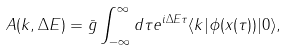Convert formula to latex. <formula><loc_0><loc_0><loc_500><loc_500>A ( k , \Delta E ) = \bar { g } \int _ { - \infty } ^ { \infty } d \tau e ^ { i \Delta E \tau } \langle k | \phi ( x ( \tau ) ) | 0 \rangle ,</formula> 